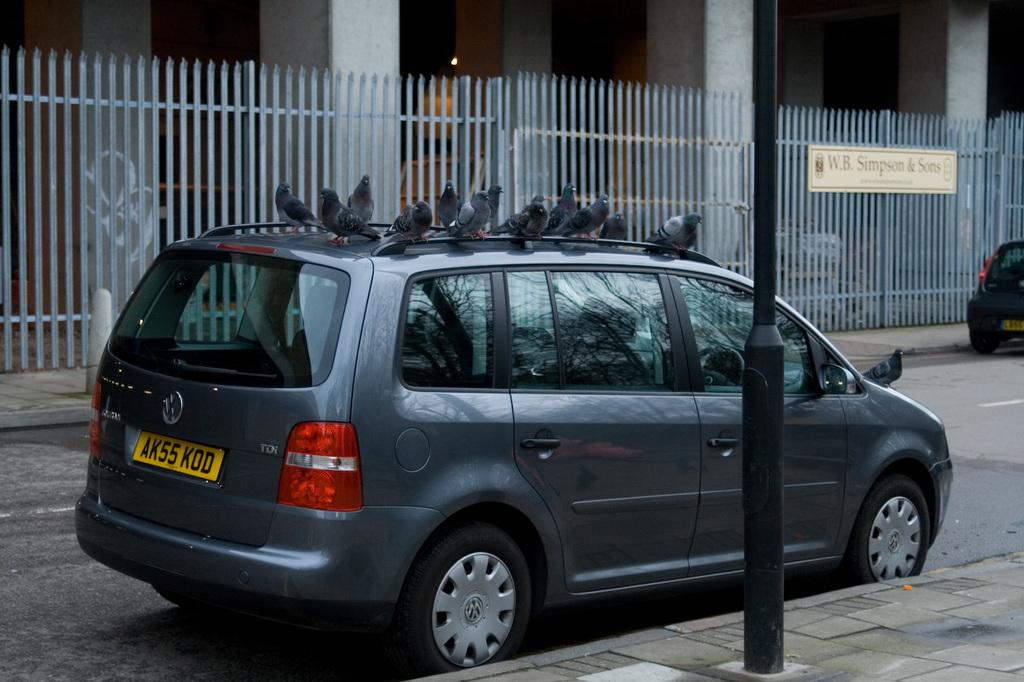<image>
Provide a brief description of the given image. A blue van is parked by a large fence that says W.B. Simpson & Sons. 